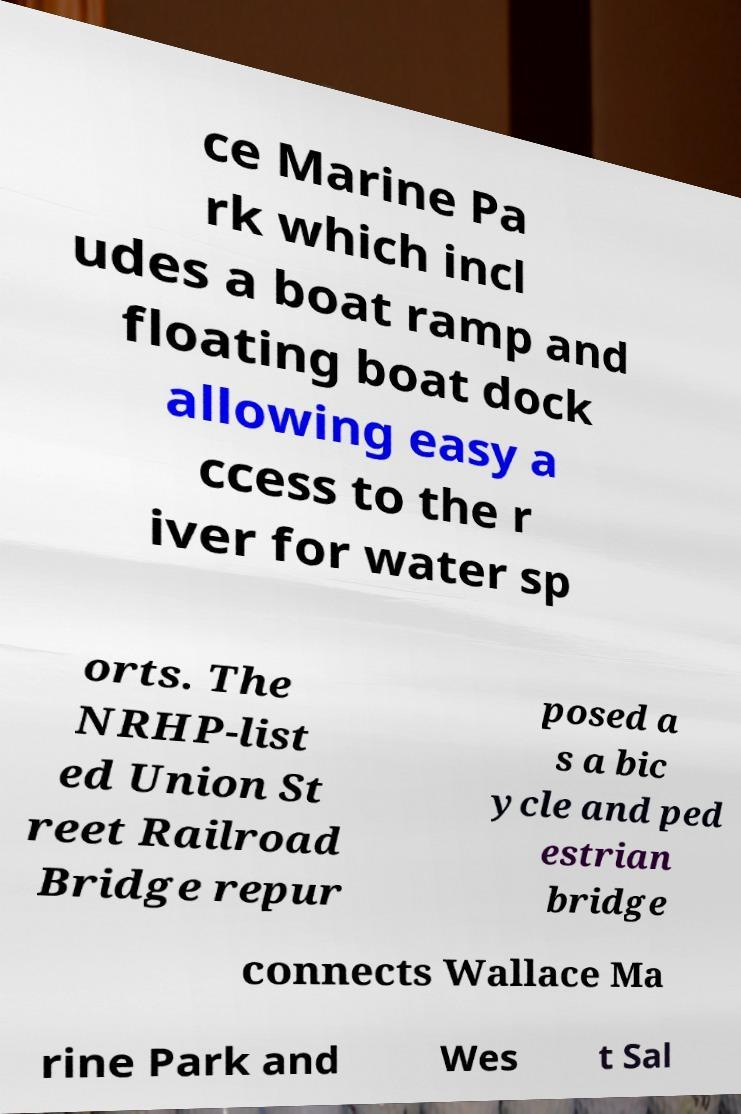There's text embedded in this image that I need extracted. Can you transcribe it verbatim? ce Marine Pa rk which incl udes a boat ramp and floating boat dock allowing easy a ccess to the r iver for water sp orts. The NRHP-list ed Union St reet Railroad Bridge repur posed a s a bic ycle and ped estrian bridge connects Wallace Ma rine Park and Wes t Sal 